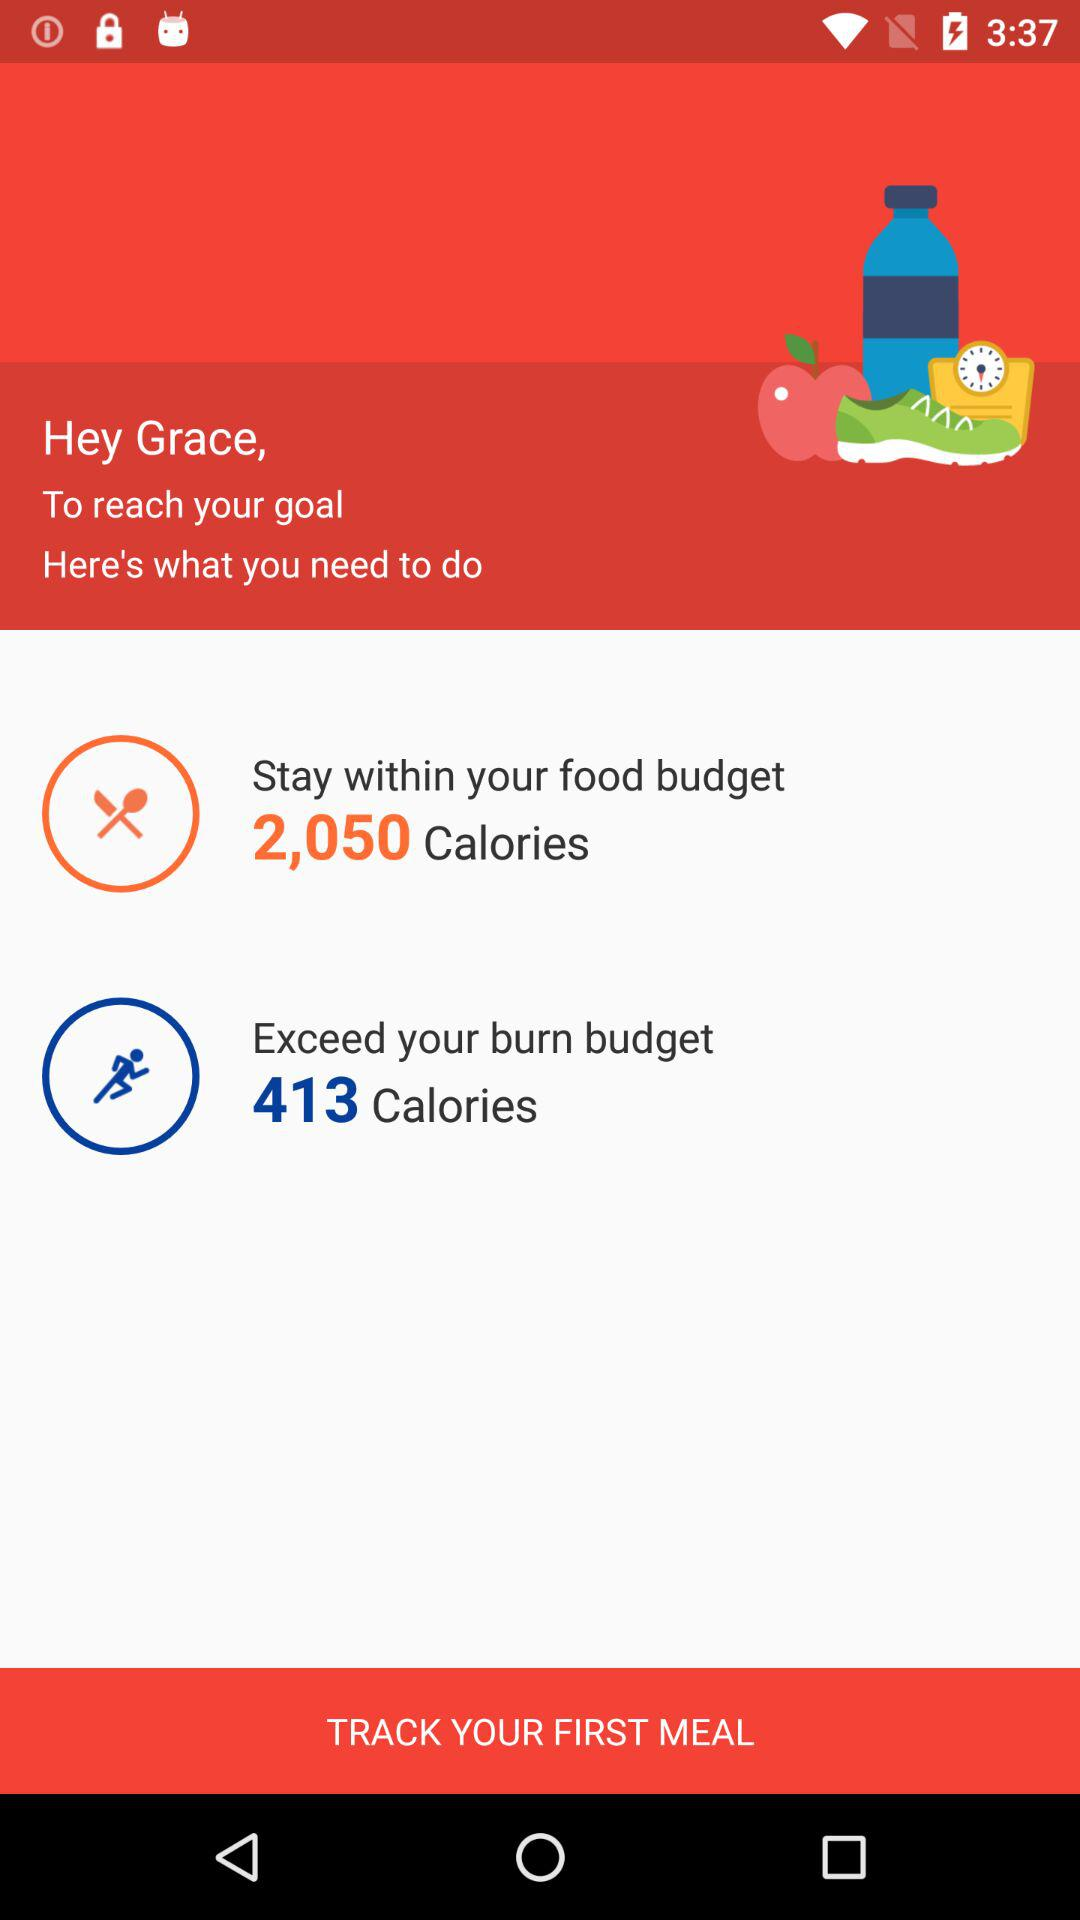What is the name of the user? The name of the user is "Grace". 